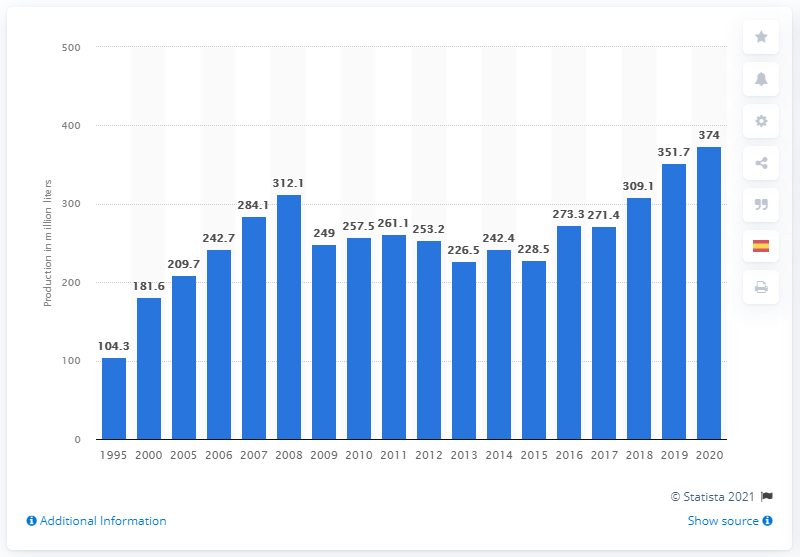Point out several critical features in this image. Mexico produced approximately 374 million liters of tequila in 2020. 